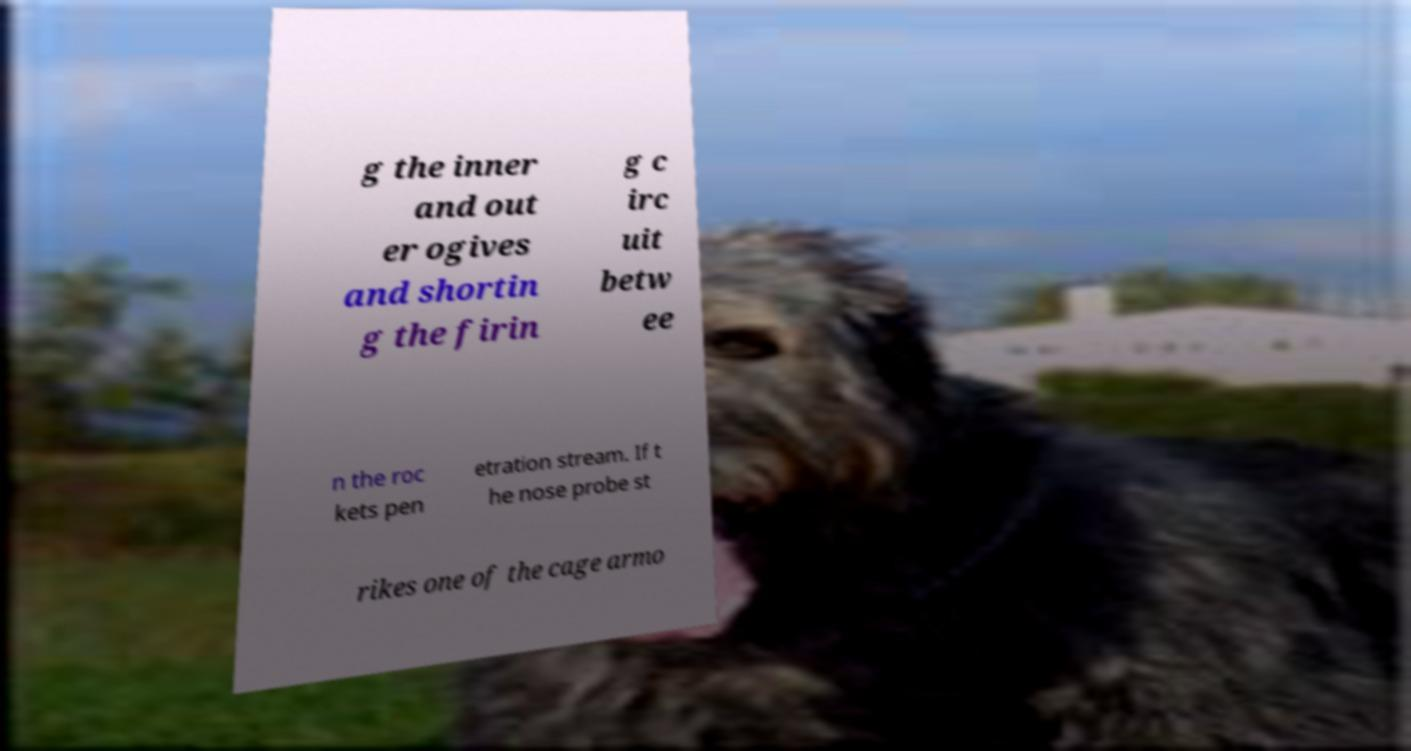I need the written content from this picture converted into text. Can you do that? g the inner and out er ogives and shortin g the firin g c irc uit betw ee n the roc kets pen etration stream. If t he nose probe st rikes one of the cage armo 